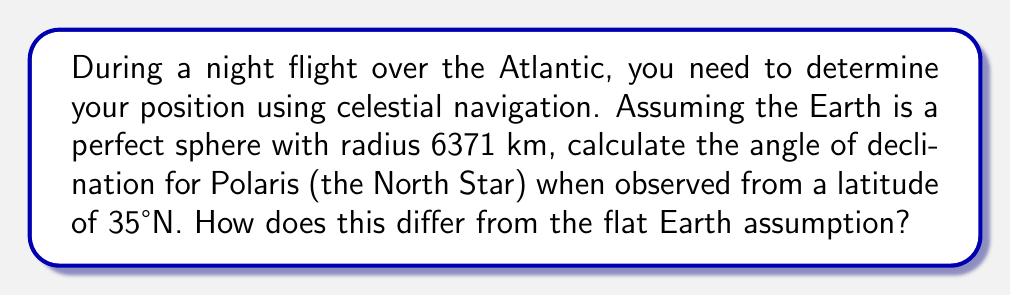Teach me how to tackle this problem. To solve this problem, we'll follow these steps:

1) On a flat Earth, the angle of declination for Polaris would simply be equal to the observer's latitude. However, on a spherical Earth, we need to account for the curvature.

2) Let's consider the geometry of the situation:

[asy]
import geometry;

unitsize(1cm);

pair O = (0,0);
pair C = (0,6.371);
pair P = (6.371*cos(radians(35)),6.371*sin(radians(35)));

draw(Circle(C,6.371));
draw(O--C--P--O);

label("Earth's Center", O, SW);
label("North Pole", C, N);
label("Observer", P, E);

draw(arc(O,1,0,35),Arrow);
label("35°", (0.7,0.3), NE);

draw(arc(P,1,90,116.9),Arrow);
label("$\theta$", (6.1,4.2), NW);

[/asy]

3) In this diagram, the observer is at point P, the Earth's center is O, and the North Pole is at C.

4) The angle we're looking for, $\theta$, is the angle between the local vertical (PC) and the direction to Polaris (parallel to OC).

5) In the triangle OPC:
   - The angle at O is 35° (the latitude)
   - OP is the Earth's radius (6371 km)
   - OC is also the Earth's radius

6) This forms an isosceles triangle. The sum of angles in a triangle is 180°, so:

   $$ 35° + \theta + \theta = 180° $$

7) Solving for $\theta$:

   $$ 2\theta = 145° $$
   $$ \theta = 72.5° $$

8) The difference from the flat Earth assumption is:

   $$ 72.5° - 35° = 37.5° $$

This significant difference demonstrates the importance of considering the Earth's curvature in celestial navigation.
Answer: $72.5°$, differing by $37.5°$ from flat Earth assumption 